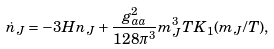Convert formula to latex. <formula><loc_0><loc_0><loc_500><loc_500>\dot { n } _ { J } = - 3 H n _ { J } + \frac { g _ { a a } ^ { 2 } } { 1 2 8 \pi ^ { 3 } } m _ { J } ^ { 3 } T K _ { 1 } ( m _ { J } / T ) ,</formula> 